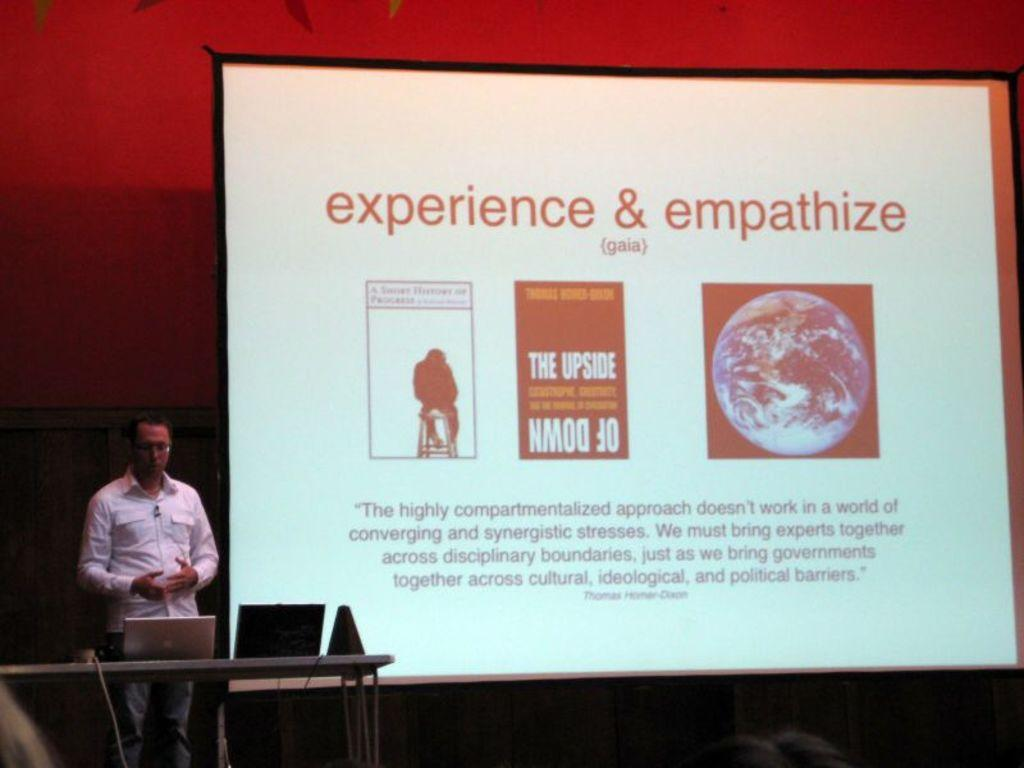Provide a one-sentence caption for the provided image. A movie screen that says experience& empathize on it. 